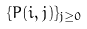<formula> <loc_0><loc_0><loc_500><loc_500>\{ P ( i , j ) \} _ { j \geq 0 }</formula> 